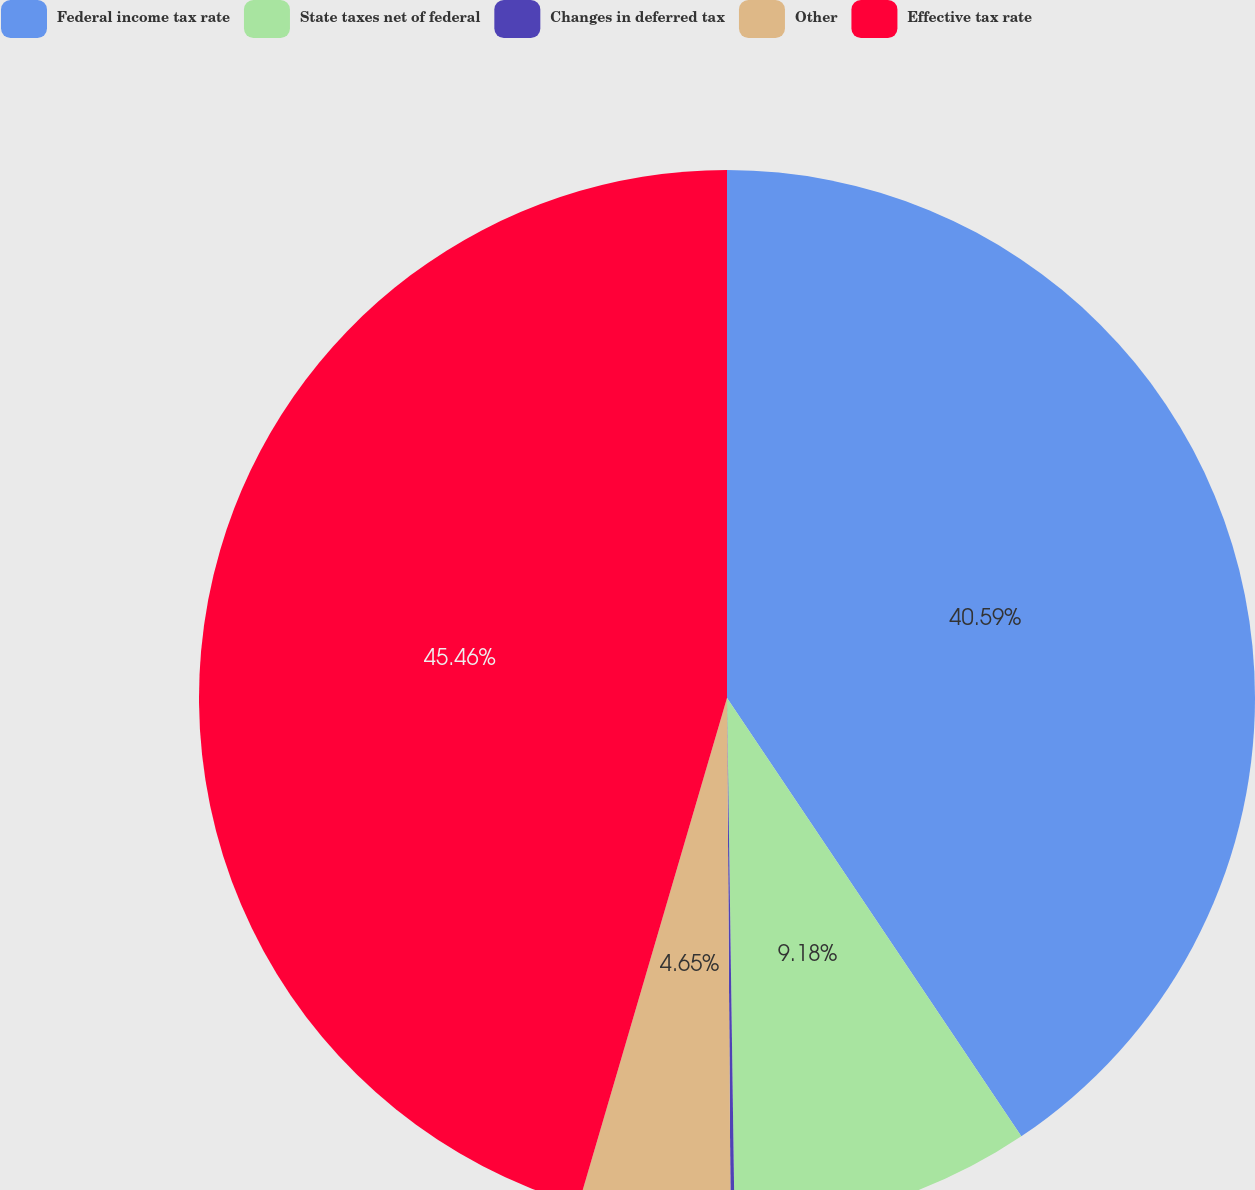Convert chart. <chart><loc_0><loc_0><loc_500><loc_500><pie_chart><fcel>Federal income tax rate<fcel>State taxes net of federal<fcel>Changes in deferred tax<fcel>Other<fcel>Effective tax rate<nl><fcel>40.59%<fcel>9.18%<fcel>0.12%<fcel>4.65%<fcel>45.46%<nl></chart> 